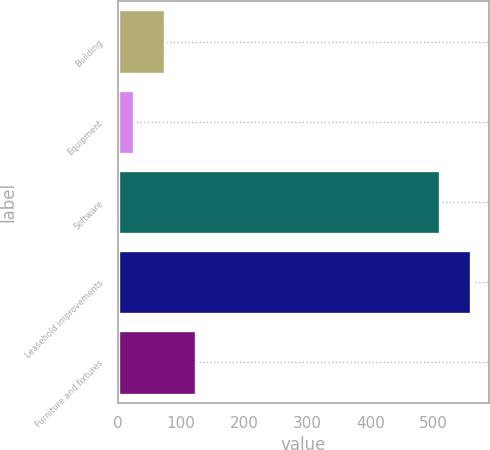Convert chart to OTSL. <chart><loc_0><loc_0><loc_500><loc_500><bar_chart><fcel>Building<fcel>Equipment<fcel>Software<fcel>Leasehold improvements<fcel>Furniture and fixtures<nl><fcel>74<fcel>25<fcel>510<fcel>559<fcel>123<nl></chart> 